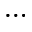Convert formula to latex. <formula><loc_0><loc_0><loc_500><loc_500>\dots</formula> 